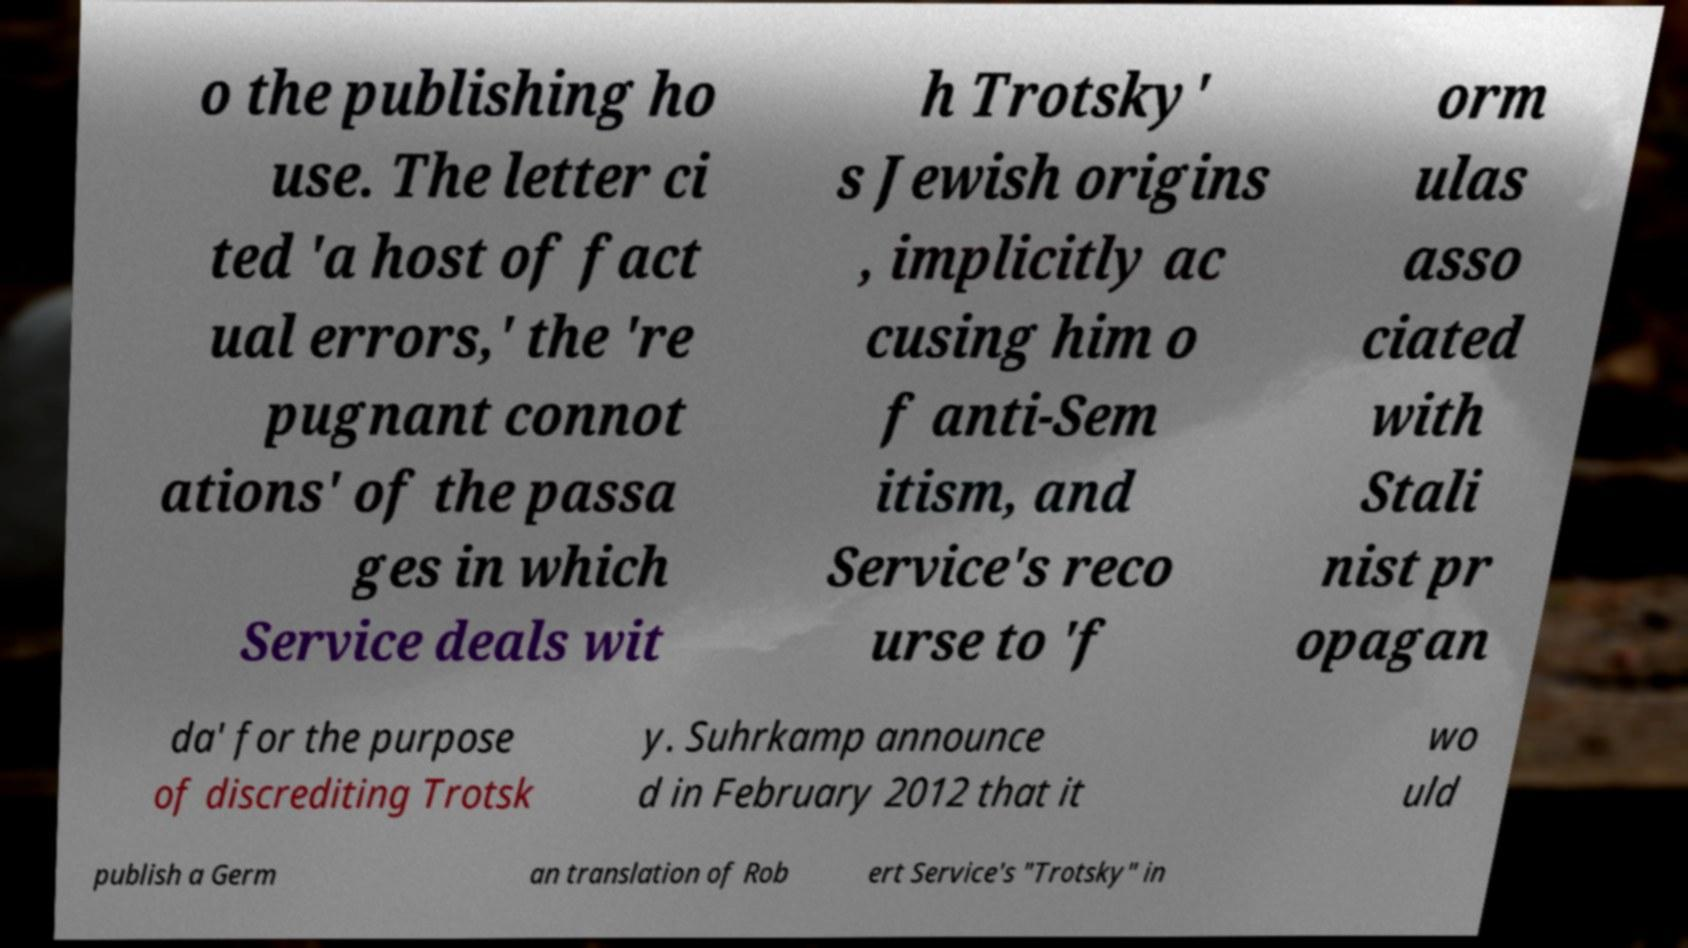Please read and relay the text visible in this image. What does it say? o the publishing ho use. The letter ci ted 'a host of fact ual errors,' the 're pugnant connot ations' of the passa ges in which Service deals wit h Trotsky' s Jewish origins , implicitly ac cusing him o f anti-Sem itism, and Service's reco urse to 'f orm ulas asso ciated with Stali nist pr opagan da' for the purpose of discrediting Trotsk y. Suhrkamp announce d in February 2012 that it wo uld publish a Germ an translation of Rob ert Service's "Trotsky" in 